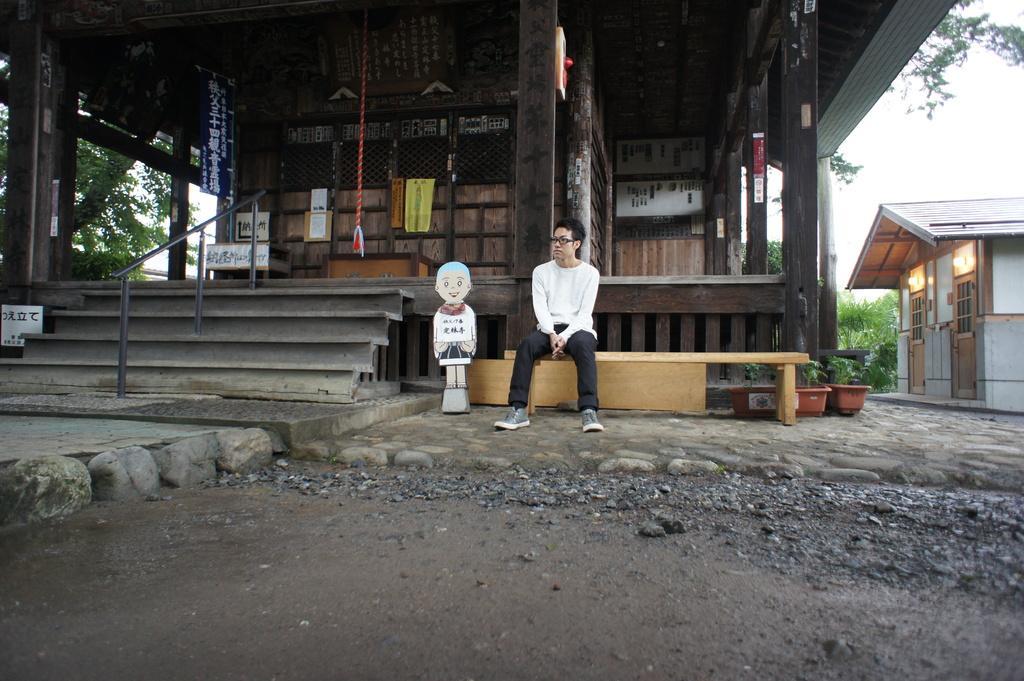Please provide a concise description of this image. In this image I can see a man sitting on bench and the building and staircase and flower pots and a toy visible in the foreground and I can see a house on the right side and I can see trees on the right side. 